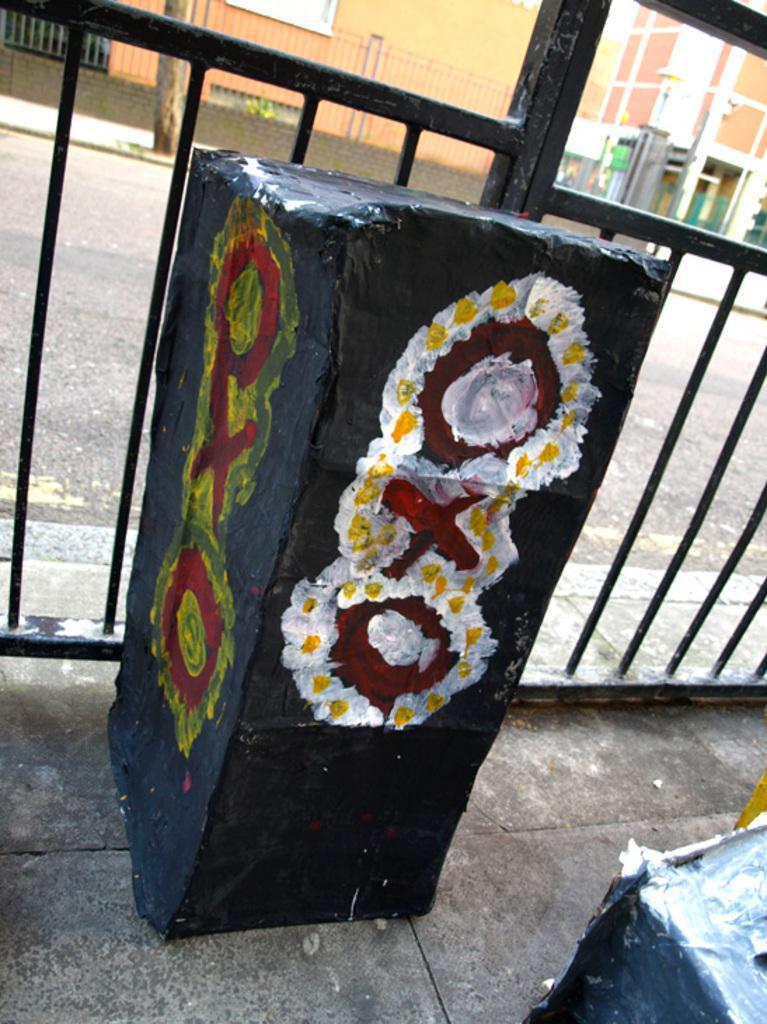How would you summarize this image in a sentence or two? In this image we can see a black color object with painting. We can also see the barrier and behind the barrier we can see the road, tree and buildings. At the bottom there is path and on the right there is another object. 